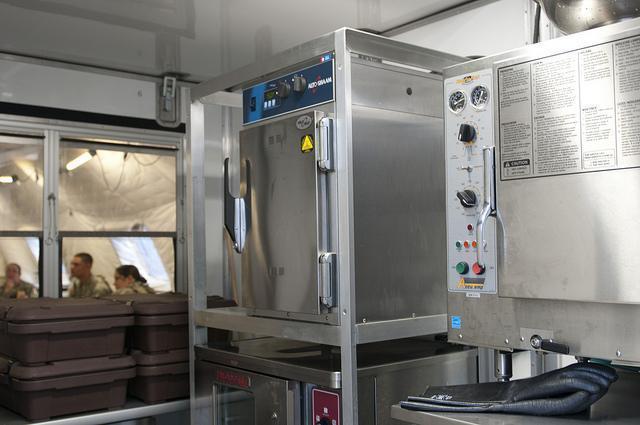What type of kitchen is this?
Select the accurate answer and provide justification: `Answer: choice
Rationale: srationale.`
Options: Island, residential, commercial, galley. Answer: commercial.
Rationale: Due to the setting and the industrial cooking devices you can tell as to where this picture was taken. 